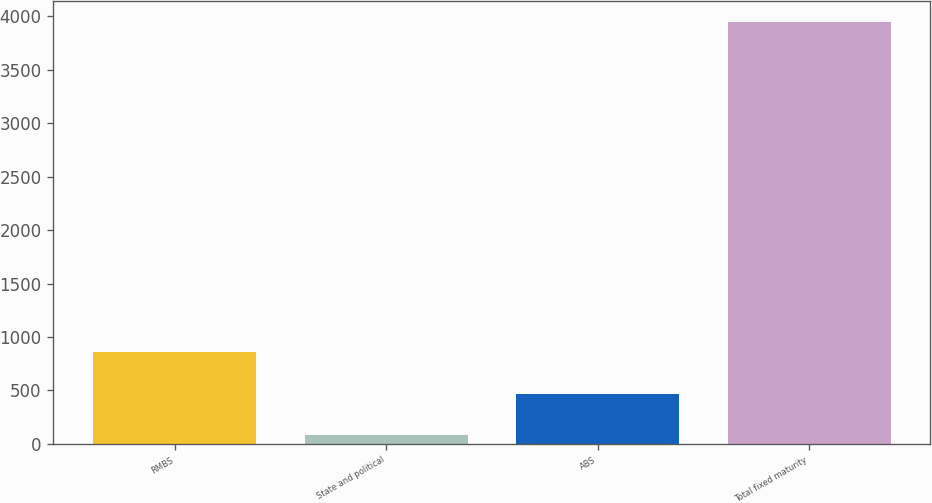Convert chart. <chart><loc_0><loc_0><loc_500><loc_500><bar_chart><fcel>RMBS<fcel>State and political<fcel>ABS<fcel>Total fixed maturity<nl><fcel>857.2<fcel>85<fcel>471.1<fcel>3946<nl></chart> 